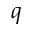<formula> <loc_0><loc_0><loc_500><loc_500>q</formula> 